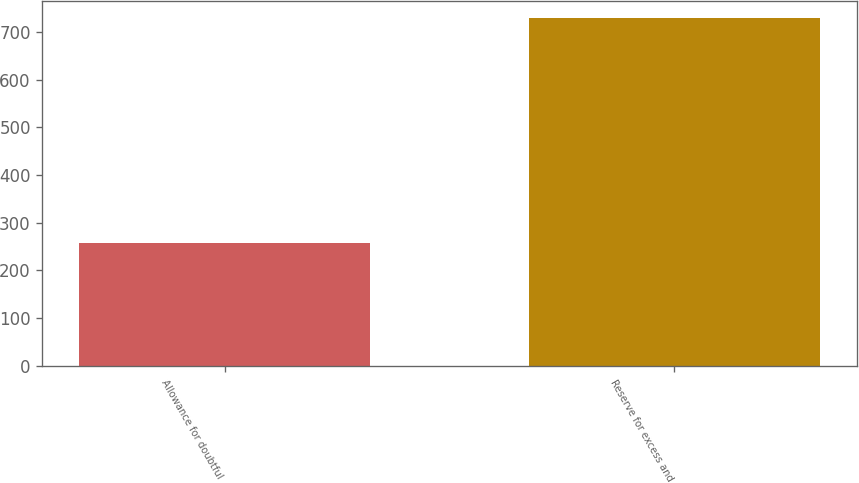<chart> <loc_0><loc_0><loc_500><loc_500><bar_chart><fcel>Allowance for doubtful<fcel>Reserve for excess and<nl><fcel>257<fcel>728<nl></chart> 